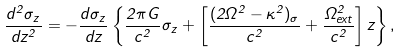<formula> <loc_0><loc_0><loc_500><loc_500>\frac { d ^ { 2 } \sigma _ { z } } { d z ^ { 2 } } = - \frac { d \sigma _ { z } } { d z } \left \{ \frac { 2 \pi G } { c ^ { 2 } } \sigma _ { z } + \left [ \frac { ( 2 \Omega ^ { 2 } - \kappa ^ { 2 } ) _ { \sigma } } { c ^ { 2 } } + \frac { \Omega _ { e x t } ^ { 2 } } { c ^ { 2 } } \right ] z \right \} ,</formula> 